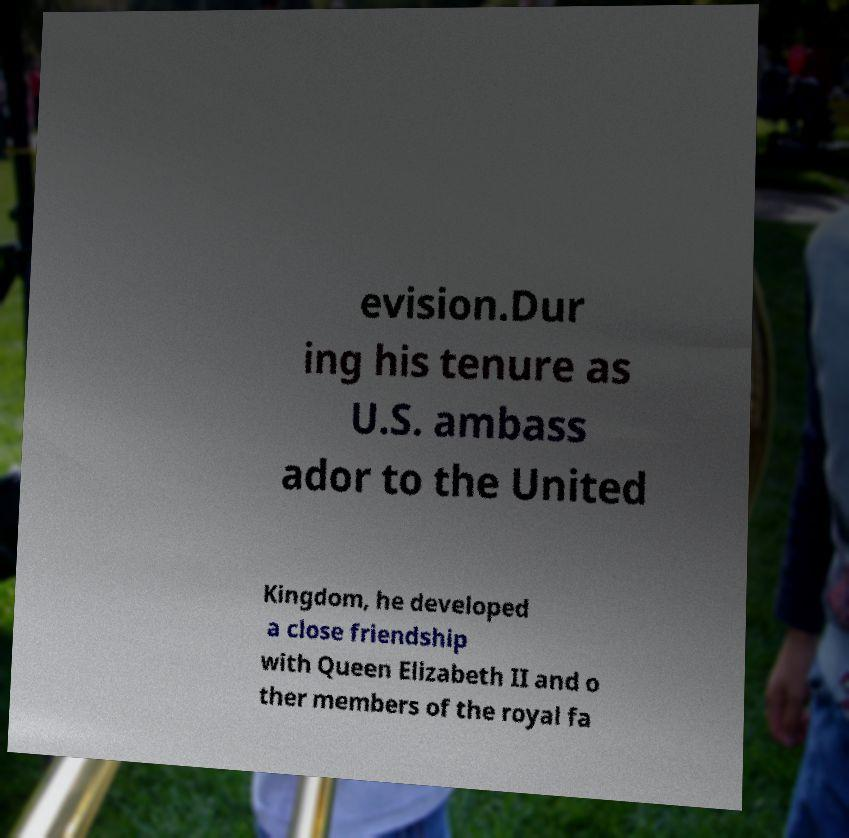I need the written content from this picture converted into text. Can you do that? evision.Dur ing his tenure as U.S. ambass ador to the United Kingdom, he developed a close friendship with Queen Elizabeth II and o ther members of the royal fa 